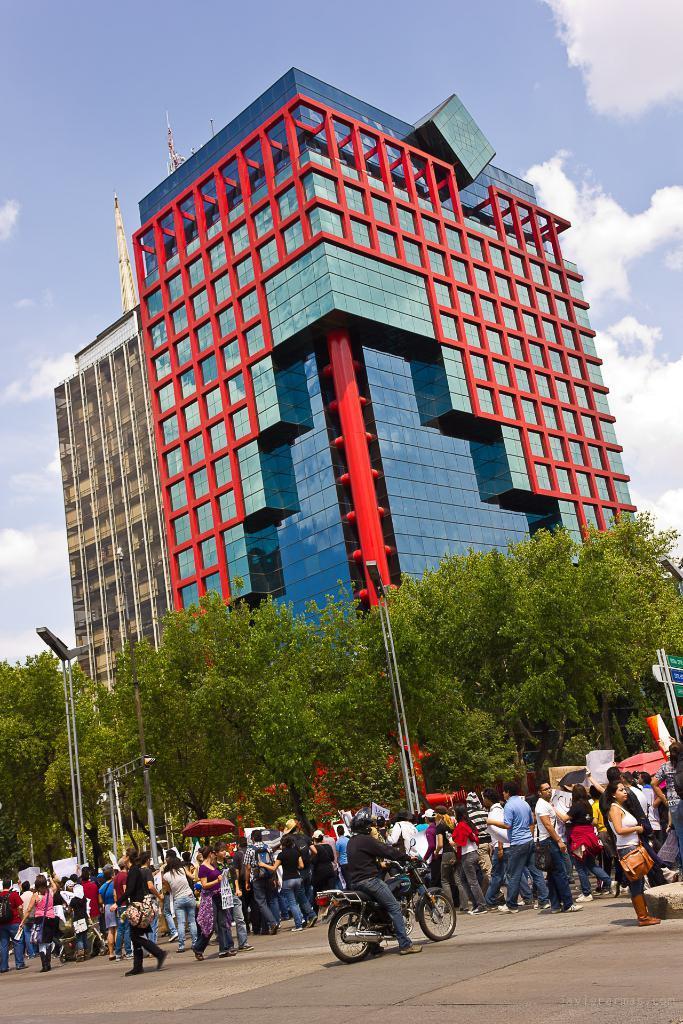Please provide a concise description of this image. In this image we can see the people standing on the ground and we can see a person sitting on the motorcycle. And we can see the building with windows and towers. There are trees, street lights and board with text. In the background, we can see the sky. 